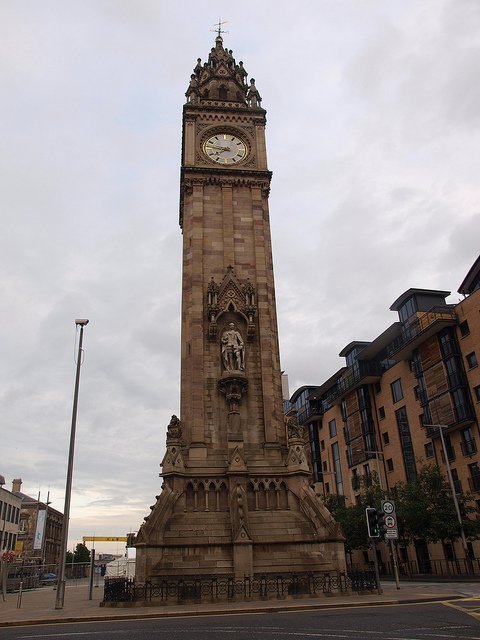Please transcribe the text information in this image. 10 